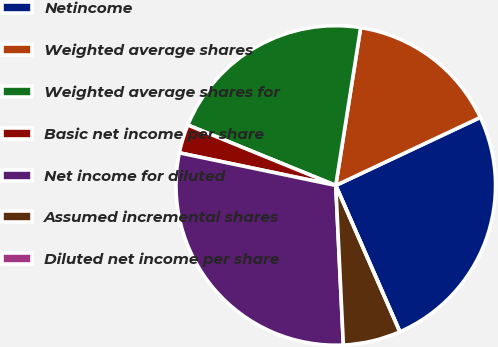Convert chart to OTSL. <chart><loc_0><loc_0><loc_500><loc_500><pie_chart><fcel>Netincome<fcel>Weighted average shares<fcel>Weighted average shares for<fcel>Basic net income per share<fcel>Net income for diluted<fcel>Assumed incremental shares<fcel>Diluted net income per share<nl><fcel>25.43%<fcel>15.51%<fcel>21.32%<fcel>2.9%<fcel>29.03%<fcel>5.81%<fcel>0.0%<nl></chart> 